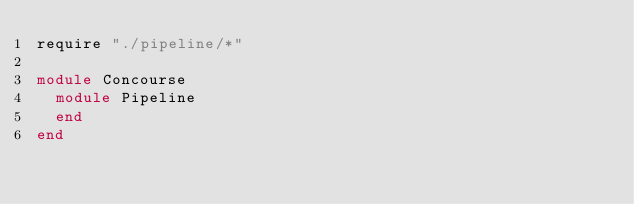Convert code to text. <code><loc_0><loc_0><loc_500><loc_500><_Crystal_>require "./pipeline/*"

module Concourse
  module Pipeline
  end
end
</code> 